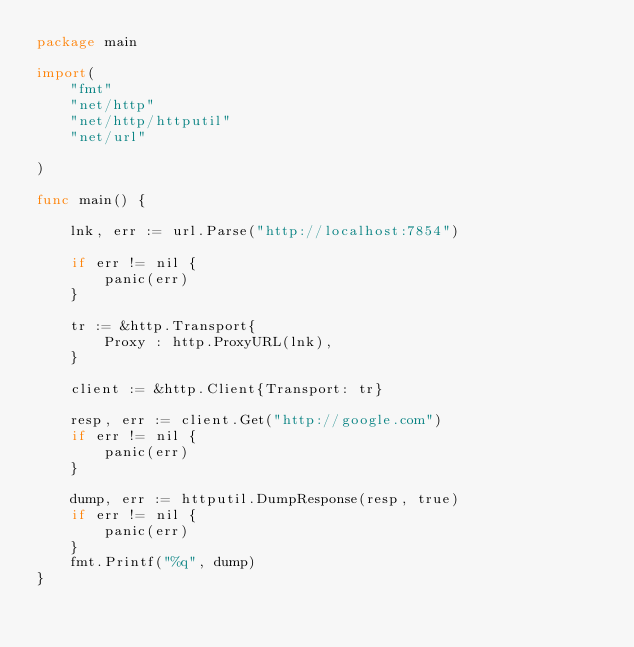<code> <loc_0><loc_0><loc_500><loc_500><_Go_>package main

import(
	"fmt"
	"net/http"
	"net/http/httputil"
	"net/url"

)

func main() {
	
	lnk, err := url.Parse("http://localhost:7854")
	
	if err != nil {
		panic(err)
	}

	tr := &http.Transport{
		Proxy : http.ProxyURL(lnk),
	}

	client := &http.Client{Transport: tr}

	resp, err := client.Get("http://google.com")
	if err != nil {
		panic(err)
	}

	dump, err := httputil.DumpResponse(resp, true)
	if err != nil {
		panic(err)
	}
	fmt.Printf("%q", dump)
}</code> 